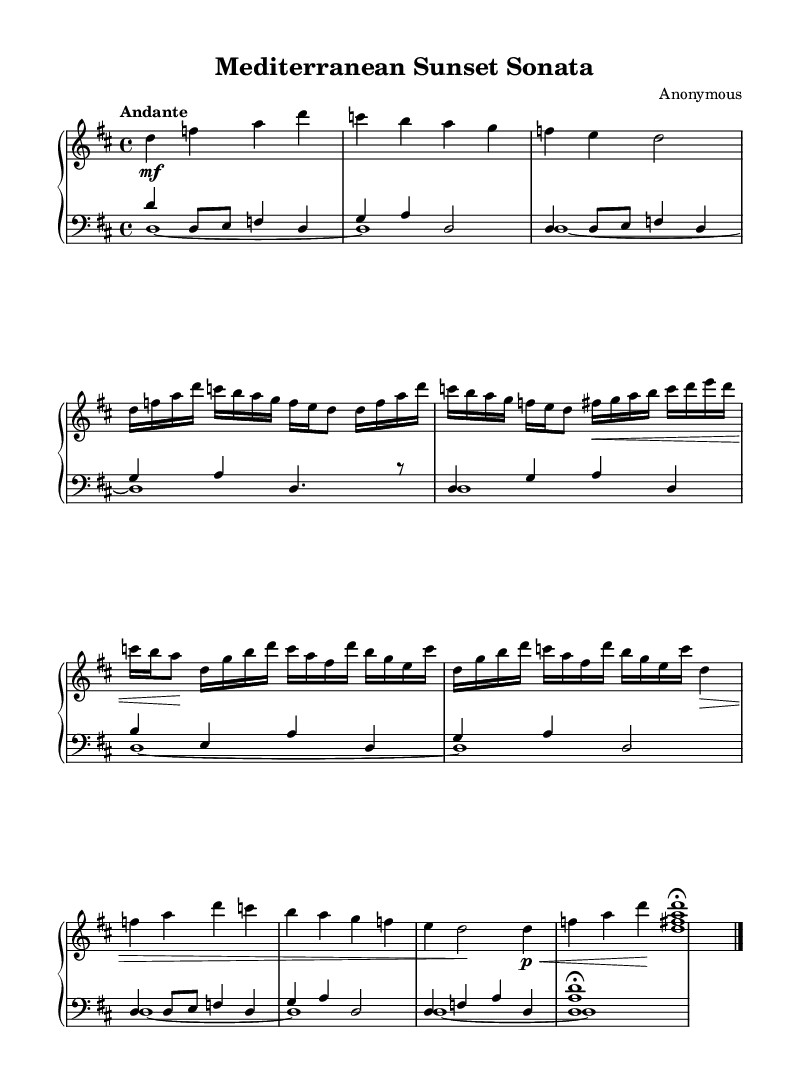What is the key signature of this music? The key signature is indicated at the beginning of the score, where it shows two sharps (F# and C#), which are characteristic of D major.
Answer: D major What is the time signature of the piece? The time signature is located at the beginning of the score after the key signature, which shows 4/4, indicating that each measure contains four beats and the quarter note gets one beat.
Answer: 4/4 What is the tempo marking of the composition? The tempo marking is indicated at the beginning with the word "Andante," which describes the speed of the piece as a moderately slow walking pace.
Answer: Andante How many measures contain Theme B? By counting the measures containing Theme B, we see that it is explicitly stated as being repeated twice, indicating that there are a total of 2 measures for Theme B.
Answer: 2 Which section of the piece repeats twice? The sheet music indicates that the "Theme A" section is marked to be repeated, as noted with the repeat sign (`\repeat unfold 2`). This confirms that Theme A occurs two times.
Answer: Theme A What clefs are used for the left hand and pedal in this score? The left hand uses the bass clef as indicated at the beginning of the left hand staff, while the pedal part is not specifically indicated with a clef, as it typically follows the manual clefs.
Answer: Bass clef for left hand; no clef for pedal What type of ornamentation might be expected in a Baroque organ composition? While this specific score lacks explicit ornamentation markings, it is common for Baroque compositions to include trills and mordents as stylistic features that enhance musical expression.
Answer: Trills and mordents 